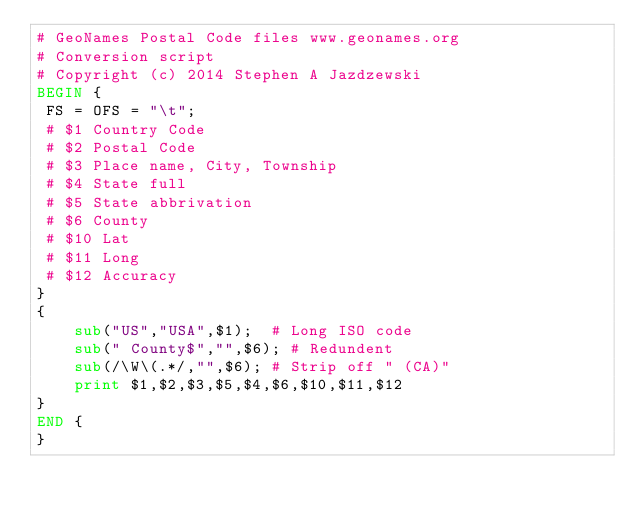<code> <loc_0><loc_0><loc_500><loc_500><_Awk_># GeoNames Postal Code files www.geonames.org
# Conversion script
# Copyright (c) 2014 Stephen A Jazdzewski
BEGIN {
 FS = OFS = "\t";
 # $1 Country Code
 # $2 Postal Code
 # $3 Place name, City, Township
 # $4 State full
 # $5 State abbrivation
 # $6 County
 # $10 Lat
 # $11 Long
 # $12 Accuracy
}
{
	sub("US","USA",$1);  # Long ISO code
	sub(" County$","",$6); # Redundent
	sub(/\W\(.*/,"",$6); # Strip off " (CA)"
	print $1,$2,$3,$5,$4,$6,$10,$11,$12
}
END {
}
</code> 